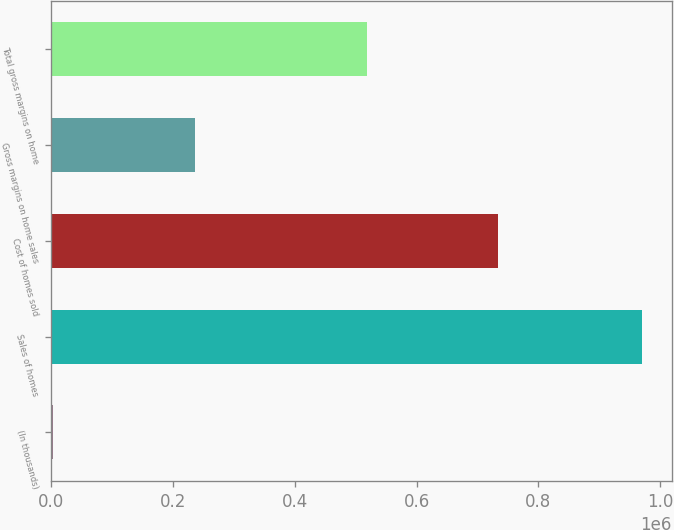Convert chart to OTSL. <chart><loc_0><loc_0><loc_500><loc_500><bar_chart><fcel>(In thousands)<fcel>Sales of homes<fcel>Cost of homes sold<fcel>Gross margins on home sales<fcel>Total gross margins on home<nl><fcel>2010<fcel>970355<fcel>734328<fcel>236027<fcel>517921<nl></chart> 